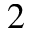<formula> <loc_0><loc_0><loc_500><loc_500>2</formula> 